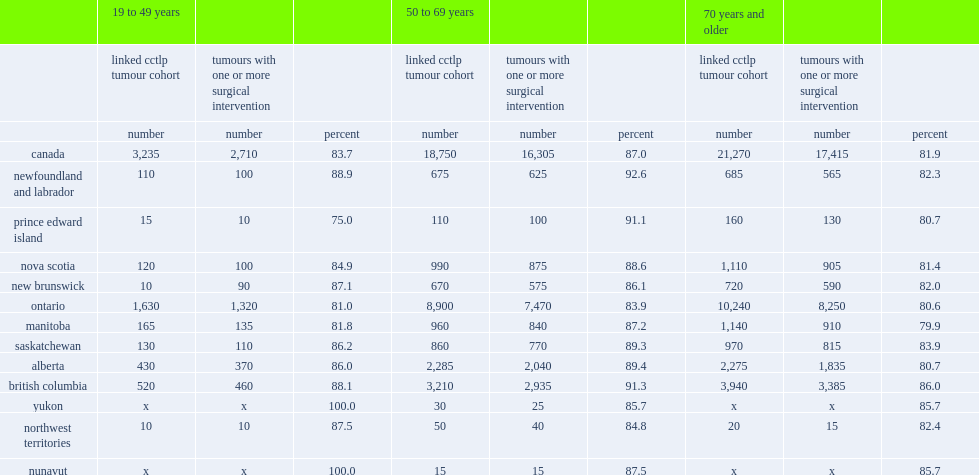Which age group has the highest surgical rates? 50 to 69 years. 